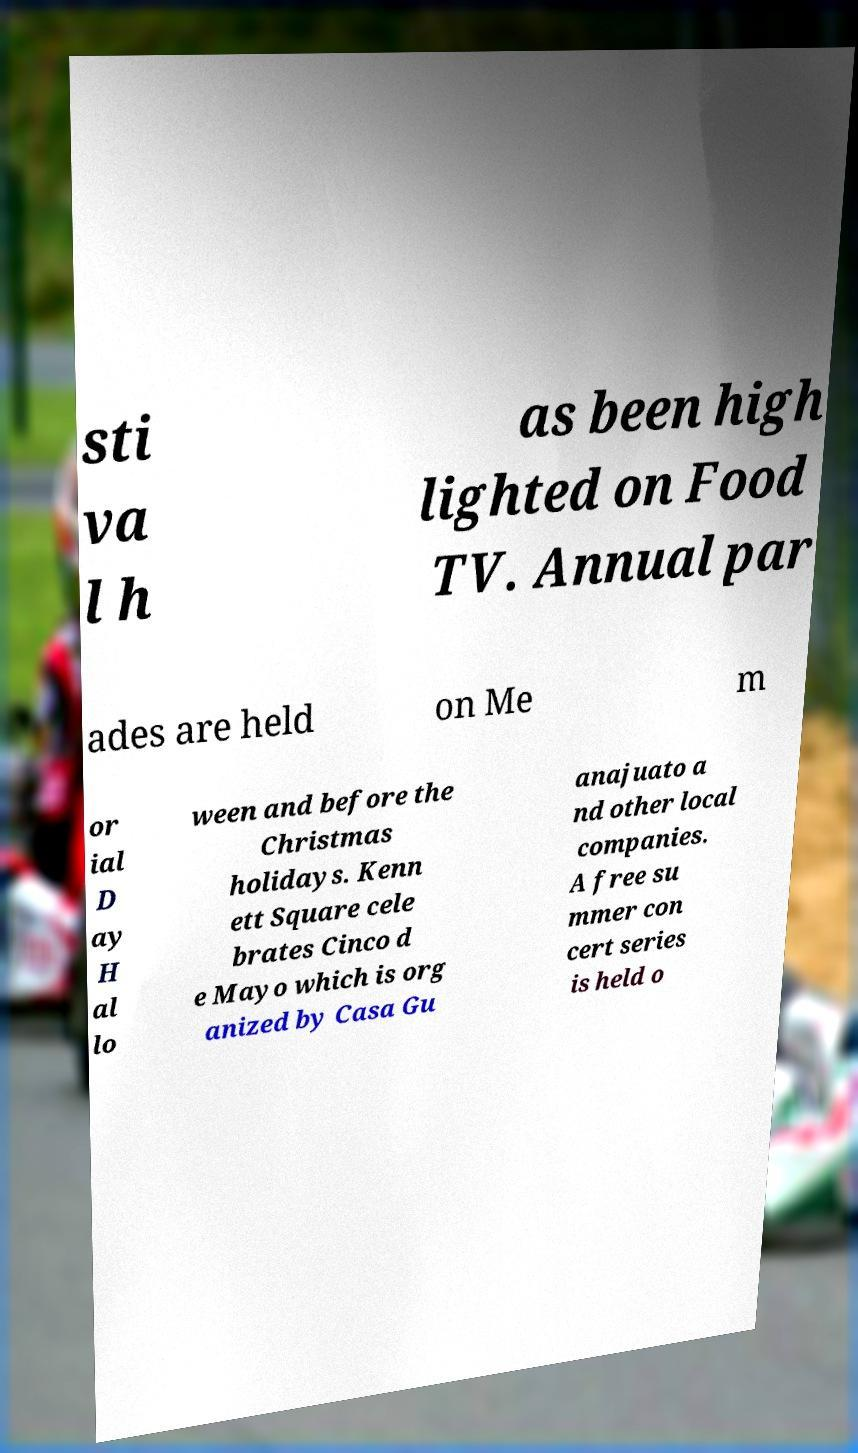Can you accurately transcribe the text from the provided image for me? sti va l h as been high lighted on Food TV. Annual par ades are held on Me m or ial D ay H al lo ween and before the Christmas holidays. Kenn ett Square cele brates Cinco d e Mayo which is org anized by Casa Gu anajuato a nd other local companies. A free su mmer con cert series is held o 